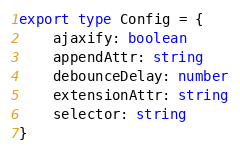Convert code to text. <code><loc_0><loc_0><loc_500><loc_500><_TypeScript_>export type Config = {
	ajaxify: boolean
	appendAttr: string
	debounceDelay: number
	extensionAttr: string
	selector: string
}
</code> 